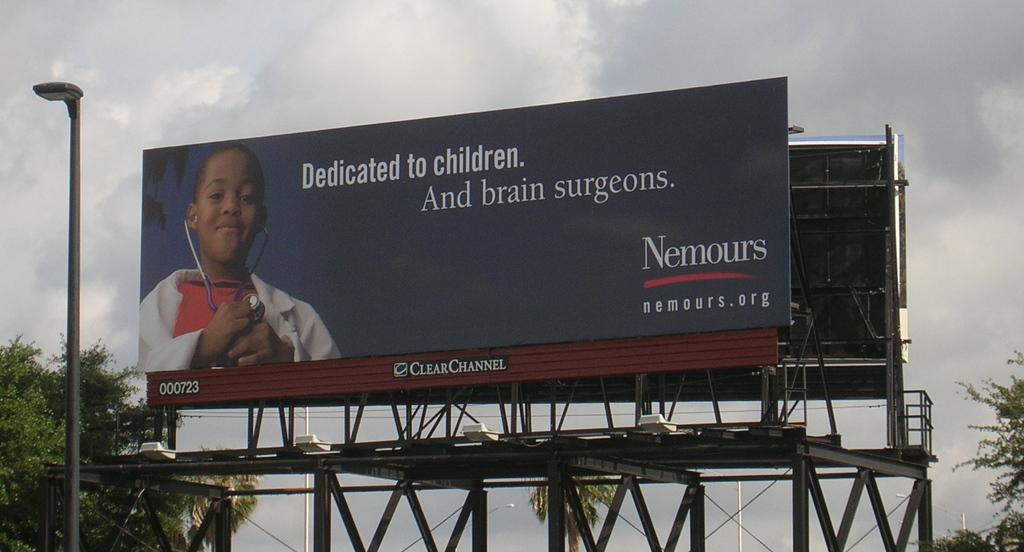<image>
Write a terse but informative summary of the picture. The billboard is dedicated to children and brain surgeons. 